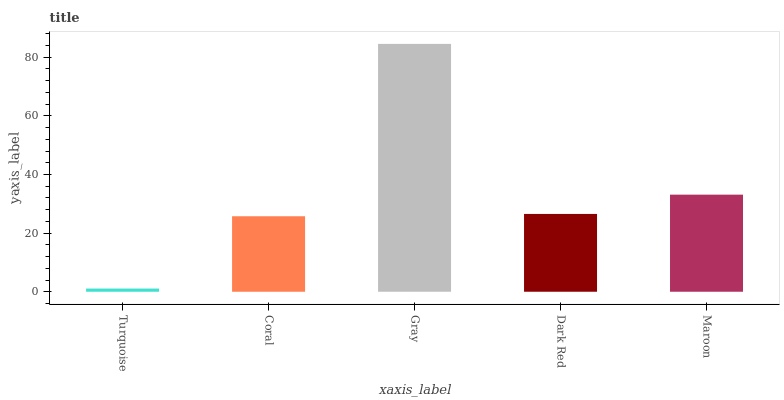Is Turquoise the minimum?
Answer yes or no. Yes. Is Gray the maximum?
Answer yes or no. Yes. Is Coral the minimum?
Answer yes or no. No. Is Coral the maximum?
Answer yes or no. No. Is Coral greater than Turquoise?
Answer yes or no. Yes. Is Turquoise less than Coral?
Answer yes or no. Yes. Is Turquoise greater than Coral?
Answer yes or no. No. Is Coral less than Turquoise?
Answer yes or no. No. Is Dark Red the high median?
Answer yes or no. Yes. Is Dark Red the low median?
Answer yes or no. Yes. Is Coral the high median?
Answer yes or no. No. Is Turquoise the low median?
Answer yes or no. No. 